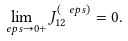Convert formula to latex. <formula><loc_0><loc_0><loc_500><loc_500>\lim _ { \ e p s \to 0 + } J _ { 1 2 } ^ { ( \ e p s ) } = 0 .</formula> 